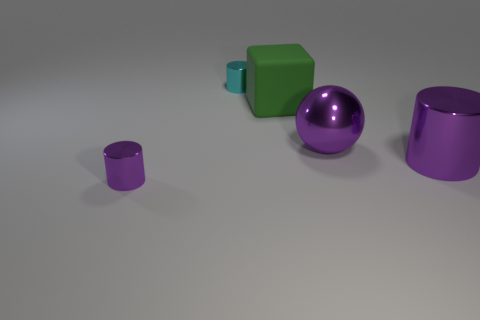Subtract all cyan cylinders. Subtract all cyan cubes. How many cylinders are left? 2 Add 5 green cylinders. How many objects exist? 10 Subtract all balls. How many objects are left? 4 Subtract all big green things. Subtract all matte things. How many objects are left? 3 Add 2 shiny things. How many shiny things are left? 6 Add 5 metallic things. How many metallic things exist? 9 Subtract 0 brown spheres. How many objects are left? 5 